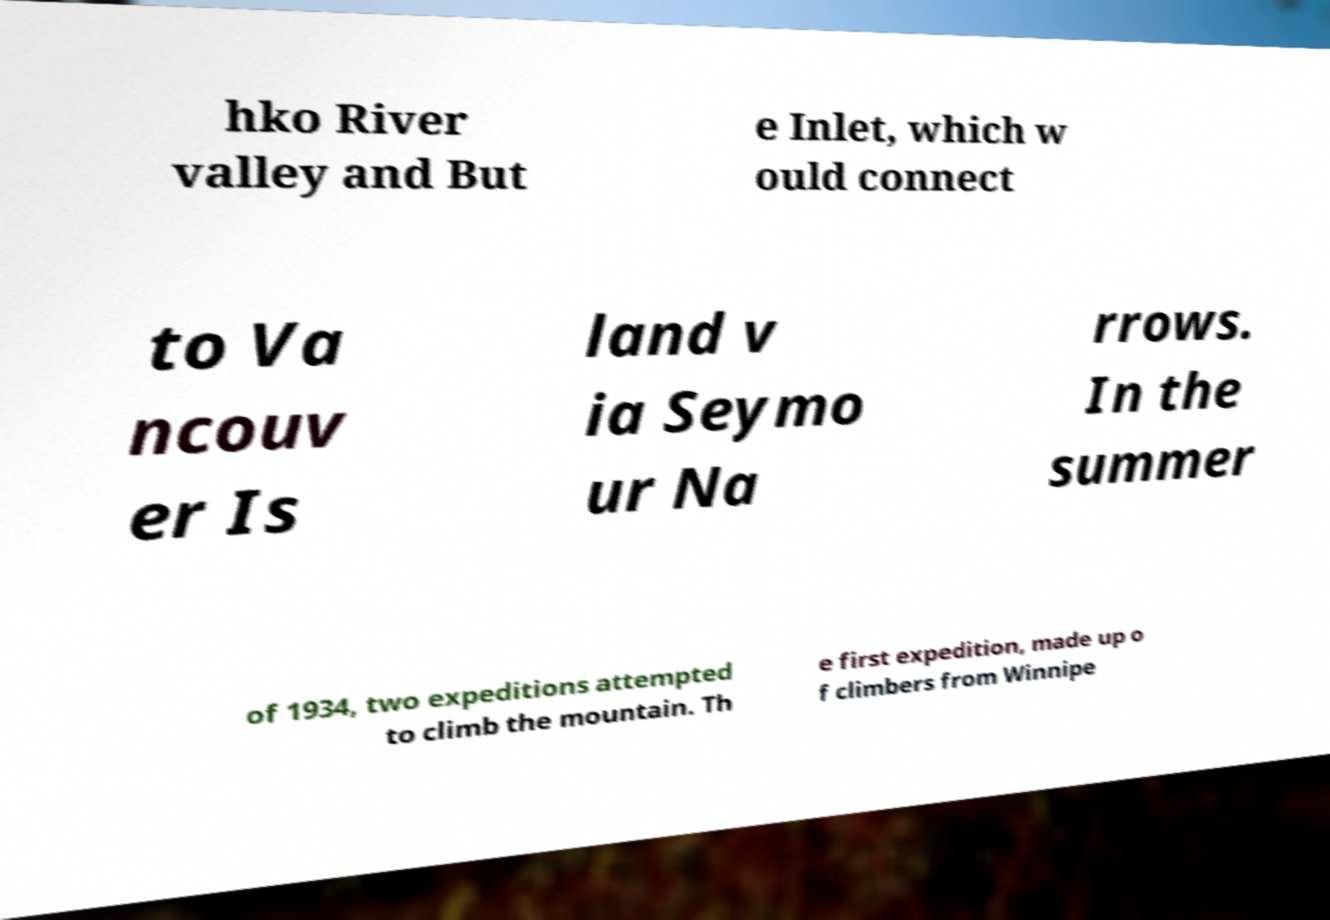Could you extract and type out the text from this image? hko River valley and But e Inlet, which w ould connect to Va ncouv er Is land v ia Seymo ur Na rrows. In the summer of 1934, two expeditions attempted to climb the mountain. Th e first expedition, made up o f climbers from Winnipe 